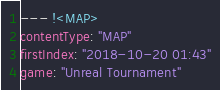Convert code to text. <code><loc_0><loc_0><loc_500><loc_500><_YAML_>--- !<MAP>
contentType: "MAP"
firstIndex: "2018-10-20 01:43"
game: "Unreal Tournament"</code> 